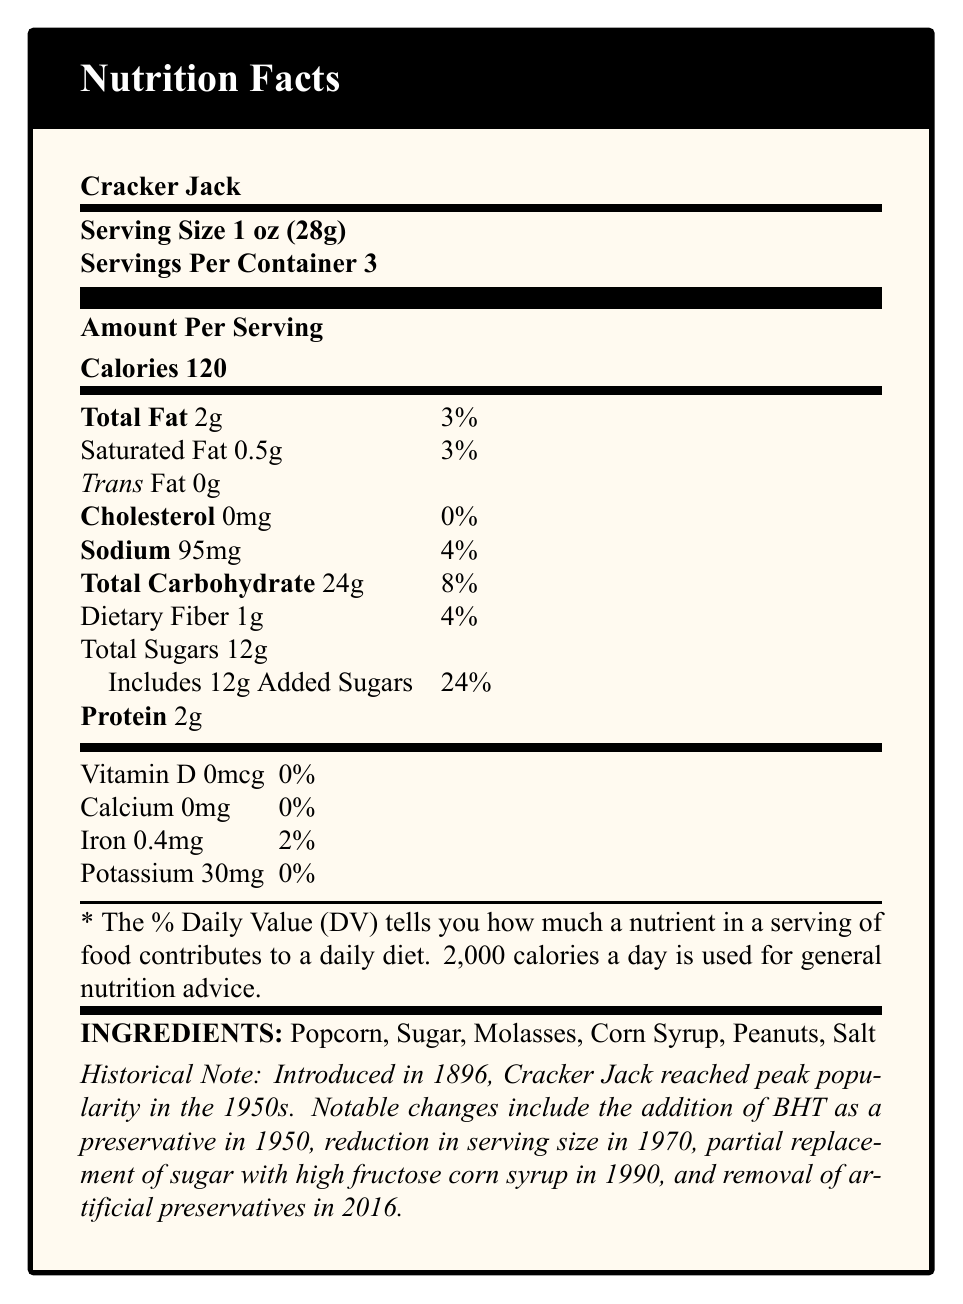what is the serving size of Cracker Jack? The document specifies that the serving size for Cracker Jack is 1 oz (28g).
Answer: 1 oz (28g) How many calories are there in one serving of Cracker Jack? According to the document, there are 120 calories per serving of Cracker Jack.
Answer: 120 What is the total fat content per serving? The Total Fat content per serving is listed as 2g in the nutritional information section.
Answer: 2g How much sodium is in a serving of Cracker Jack? The sodium content per serving is specified as 95mg.
Answer: 95mg How much protein does one serving of Cracker Jack contain? The document states that one serving of Cracker Jack contains 2g of protein.
Answer: 2g From the list of ingredients, identify the main sweeteners used in Cracker Jack. The ingredients section lists Sugar, Molasses, and Corn Syrup as sweeteners used.
Answer: Sugar, Molasses, Corn Syrup What percentage of the daily value of added sugars does one serving of Cracker Jack provide? A. 8% B. 12% C. 24% D. 48% The document states that the added sugars amount to 24% of the daily value per serving.
Answer: C. 24% Which year did Cracker Jack remove artificial preservatives? A. 1950 B. 1970 C. 1990 D. 2016 The document notes that artificial preservatives were removed in 2016 due to consumer demand for natural ingredients.
Answer: D. 2016 Is there any cholesterol present in a serving of Cracker Jack? The nutritional facts state that there is 0mg of cholesterol per serving.
Answer: No Summarize the main changes to Cracker Jack over time as described in the document. The document outlines a historical context highlighting key changes such as the addition and later removal of preservatives, as well as changes in ingredients and serving size for economic and consumer preferences.
Answer: Cracker Jack was introduced in 1896 and became popular in the 1950s. Over time, it saw the addition of BHT as a preservative in 1950, a reduction in serving size in 1970 due to rising production costs, partial replacement of sugar with high fructose corn syrup in 1990 for cost-effectiveness, and the removal of artificial preservatives in 2016 because of consumer demand. Which vitamin is completely absent in Cracker Jack? The document indicates that Vitamin D is 0mcg, meaning it is completely absent.
Answer: Vitamin D What is the iron content per serving of Cracker Jack? The iron content per serving is listed as 0.4mg in the nutritional information.
Answer: 0.4mg Cracker Jack was mentioned in which literary work by Truman Capote? The document cites "Breakfast at Tiffany's" by Truman Capote as one of the works mentioning Cracker Jack.
Answer: Breakfast at Tiffany's Based on the document, can the precise impact of World War II rationing on Cracker Jack production be determined? The document only states that there was a temporary reduction in production during World War II but does not provide precise details on the impact.
Answer: Not enough information 